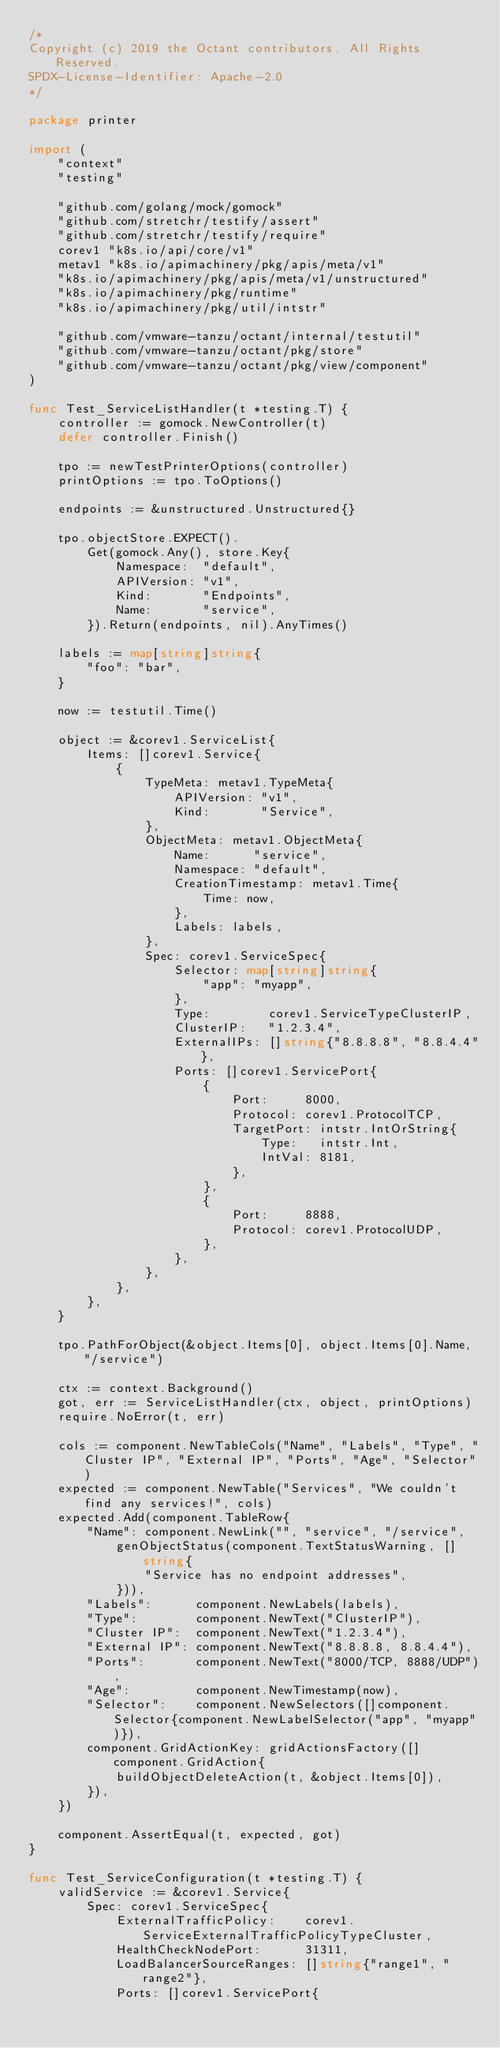Convert code to text. <code><loc_0><loc_0><loc_500><loc_500><_Go_>/*
Copyright (c) 2019 the Octant contributors. All Rights Reserved.
SPDX-License-Identifier: Apache-2.0
*/

package printer

import (
	"context"
	"testing"

	"github.com/golang/mock/gomock"
	"github.com/stretchr/testify/assert"
	"github.com/stretchr/testify/require"
	corev1 "k8s.io/api/core/v1"
	metav1 "k8s.io/apimachinery/pkg/apis/meta/v1"
	"k8s.io/apimachinery/pkg/apis/meta/v1/unstructured"
	"k8s.io/apimachinery/pkg/runtime"
	"k8s.io/apimachinery/pkg/util/intstr"

	"github.com/vmware-tanzu/octant/internal/testutil"
	"github.com/vmware-tanzu/octant/pkg/store"
	"github.com/vmware-tanzu/octant/pkg/view/component"
)

func Test_ServiceListHandler(t *testing.T) {
	controller := gomock.NewController(t)
	defer controller.Finish()

	tpo := newTestPrinterOptions(controller)
	printOptions := tpo.ToOptions()

	endpoints := &unstructured.Unstructured{}

	tpo.objectStore.EXPECT().
		Get(gomock.Any(), store.Key{
			Namespace:  "default",
			APIVersion: "v1",
			Kind:       "Endpoints",
			Name:       "service",
		}).Return(endpoints, nil).AnyTimes()

	labels := map[string]string{
		"foo": "bar",
	}

	now := testutil.Time()

	object := &corev1.ServiceList{
		Items: []corev1.Service{
			{
				TypeMeta: metav1.TypeMeta{
					APIVersion: "v1",
					Kind:       "Service",
				},
				ObjectMeta: metav1.ObjectMeta{
					Name:      "service",
					Namespace: "default",
					CreationTimestamp: metav1.Time{
						Time: now,
					},
					Labels: labels,
				},
				Spec: corev1.ServiceSpec{
					Selector: map[string]string{
						"app": "myapp",
					},
					Type:        corev1.ServiceTypeClusterIP,
					ClusterIP:   "1.2.3.4",
					ExternalIPs: []string{"8.8.8.8", "8.8.4.4"},
					Ports: []corev1.ServicePort{
						{
							Port:     8000,
							Protocol: corev1.ProtocolTCP,
							TargetPort: intstr.IntOrString{
								Type:   intstr.Int,
								IntVal: 8181,
							},
						},
						{
							Port:     8888,
							Protocol: corev1.ProtocolUDP,
						},
					},
				},
			},
		},
	}

	tpo.PathForObject(&object.Items[0], object.Items[0].Name, "/service")

	ctx := context.Background()
	got, err := ServiceListHandler(ctx, object, printOptions)
	require.NoError(t, err)

	cols := component.NewTableCols("Name", "Labels", "Type", "Cluster IP", "External IP", "Ports", "Age", "Selector")
	expected := component.NewTable("Services", "We couldn't find any services!", cols)
	expected.Add(component.TableRow{
		"Name": component.NewLink("", "service", "/service",
			genObjectStatus(component.TextStatusWarning, []string{
				"Service has no endpoint addresses",
			})),
		"Labels":      component.NewLabels(labels),
		"Type":        component.NewText("ClusterIP"),
		"Cluster IP":  component.NewText("1.2.3.4"),
		"External IP": component.NewText("8.8.8.8, 8.8.4.4"),
		"Ports":       component.NewText("8000/TCP, 8888/UDP"),
		"Age":         component.NewTimestamp(now),
		"Selector":    component.NewSelectors([]component.Selector{component.NewLabelSelector("app", "myapp")}),
		component.GridActionKey: gridActionsFactory([]component.GridAction{
			buildObjectDeleteAction(t, &object.Items[0]),
		}),
	})

	component.AssertEqual(t, expected, got)
}

func Test_ServiceConfiguration(t *testing.T) {
	validService := &corev1.Service{
		Spec: corev1.ServiceSpec{
			ExternalTrafficPolicy:    corev1.ServiceExternalTrafficPolicyTypeCluster,
			HealthCheckNodePort:      31311,
			LoadBalancerSourceRanges: []string{"range1", "range2"},
			Ports: []corev1.ServicePort{</code> 